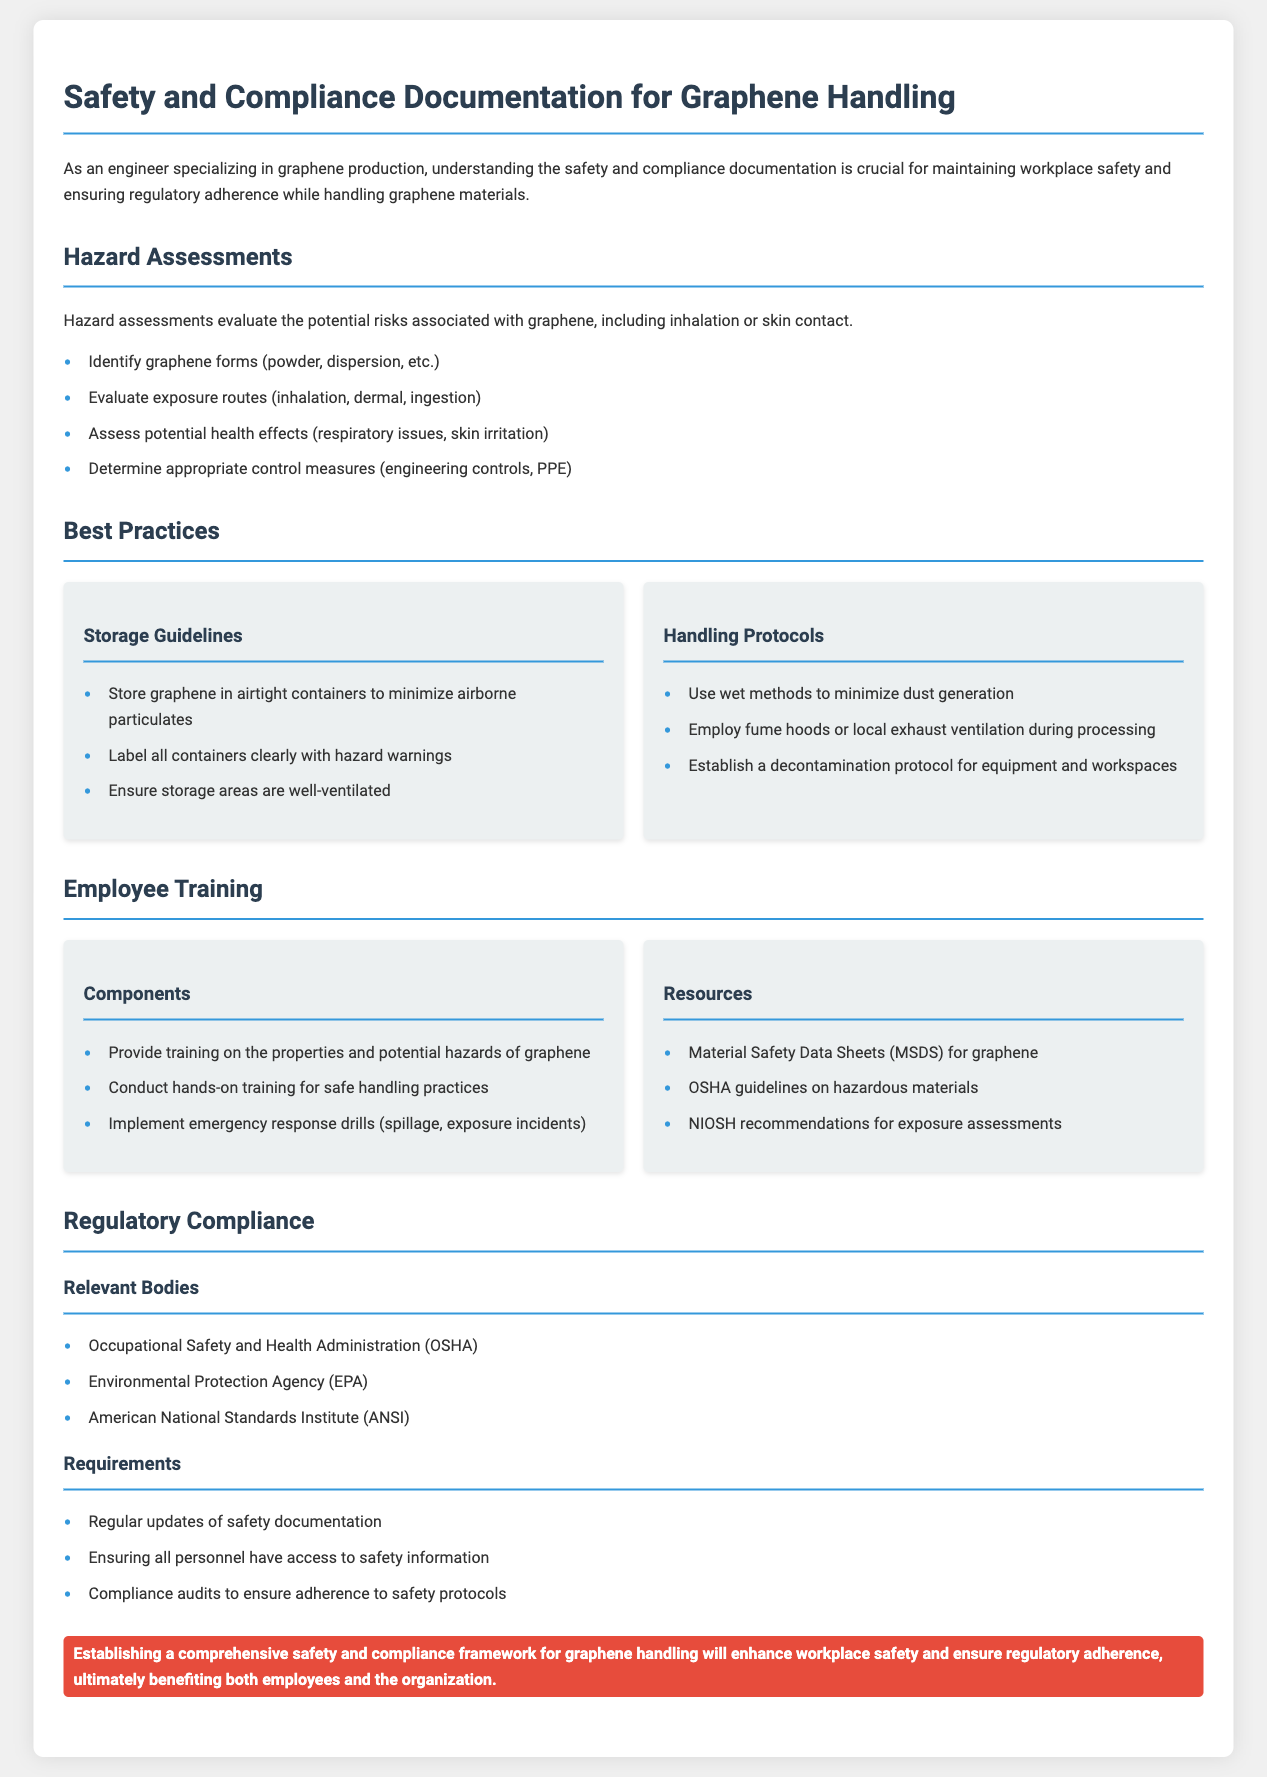What are the potential health effects of graphene? The document mentions that potential health effects include respiratory issues and skin irritation.
Answer: Respiratory issues, skin irritation Which organization is responsible for occupational safety? The document lists the Occupational Safety and Health Administration as the relevant body for occupational safety.
Answer: OSHA What type of containers should graphene be stored in? The best practices section indicates that graphene should be stored in airtight containers.
Answer: Airtight containers What are two exposure routes listed for graphene? The hazard assessments section evaluates exposure routes including inhalation and dermal.
Answer: Inhalation, dermal What type of training should employees receive for handling graphene? The employee training section emphasizes that training on the properties and potential hazards of graphene should be provided.
Answer: Properties and potential hazards Which governmental body focuses on environmental regulations? The document lists the Environmental Protection Agency as a relevant body for environmental compliance.
Answer: EPA What is one aspect of handling protocols? The handling protocols section suggests using wet methods to minimize dust generation as a best practice.
Answer: Use wet methods How many relevant bodies are listed in the regulatory compliance section? The document lists three relevant bodies in the regulatory compliance section.
Answer: Three 